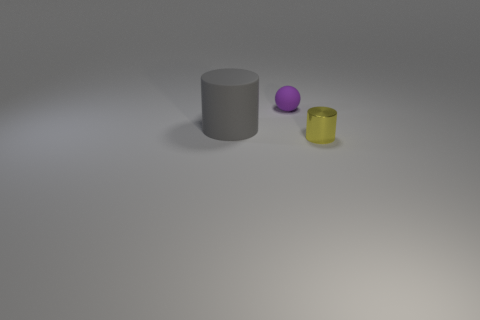Add 2 tiny cylinders. How many objects exist? 5 Subtract all cylinders. How many objects are left? 1 Add 3 red shiny cylinders. How many red shiny cylinders exist? 3 Subtract 0 blue spheres. How many objects are left? 3 Subtract all green spheres. Subtract all purple cylinders. How many spheres are left? 1 Subtract all purple rubber balls. Subtract all large rubber objects. How many objects are left? 1 Add 3 small metal things. How many small metal things are left? 4 